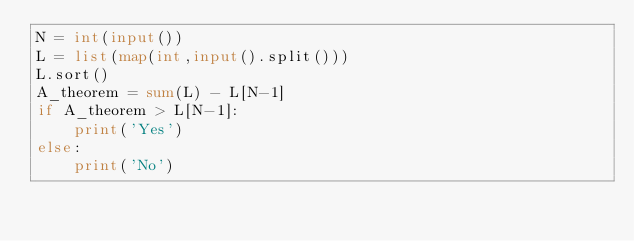Convert code to text. <code><loc_0><loc_0><loc_500><loc_500><_Python_>N = int(input())
L = list(map(int,input().split()))
L.sort()
A_theorem = sum(L) - L[N-1]
if A_theorem > L[N-1]:
    print('Yes')
else:
    print('No')

</code> 